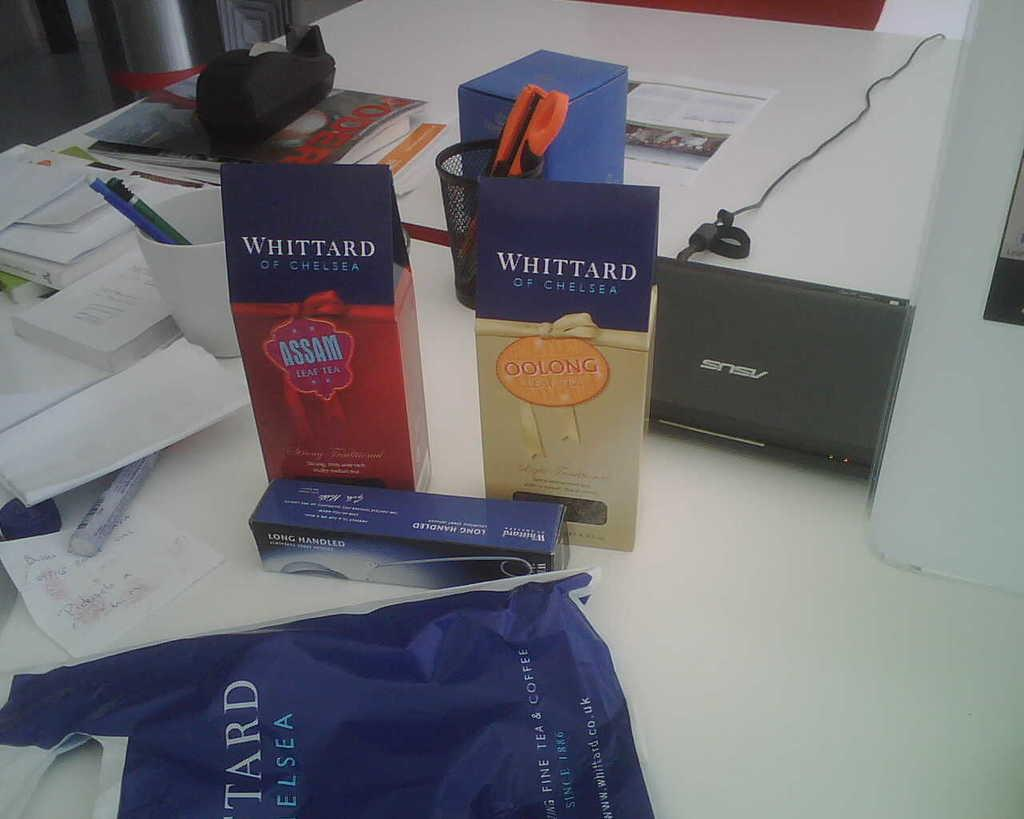<image>
Present a compact description of the photo's key features. a desk that has two Whittard of Chelsea bags on it 